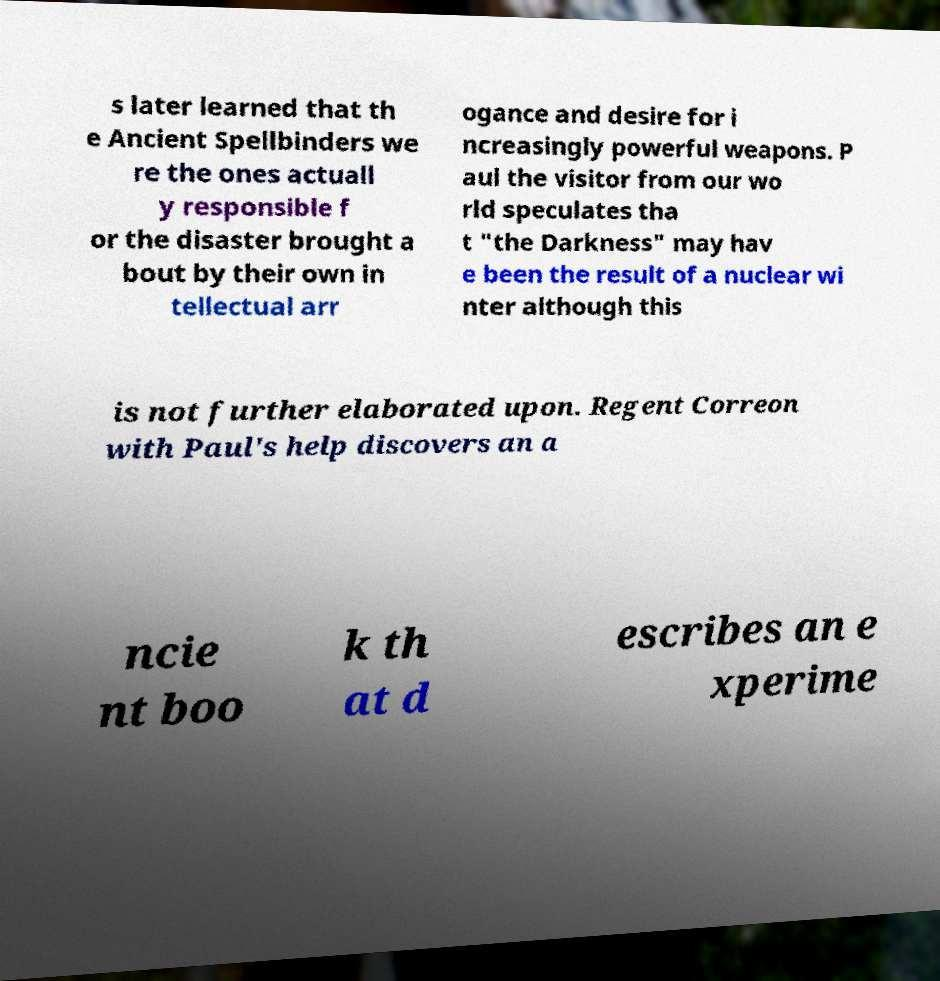What messages or text are displayed in this image? I need them in a readable, typed format. s later learned that th e Ancient Spellbinders we re the ones actuall y responsible f or the disaster brought a bout by their own in tellectual arr ogance and desire for i ncreasingly powerful weapons. P aul the visitor from our wo rld speculates tha t "the Darkness" may hav e been the result of a nuclear wi nter although this is not further elaborated upon. Regent Correon with Paul's help discovers an a ncie nt boo k th at d escribes an e xperime 